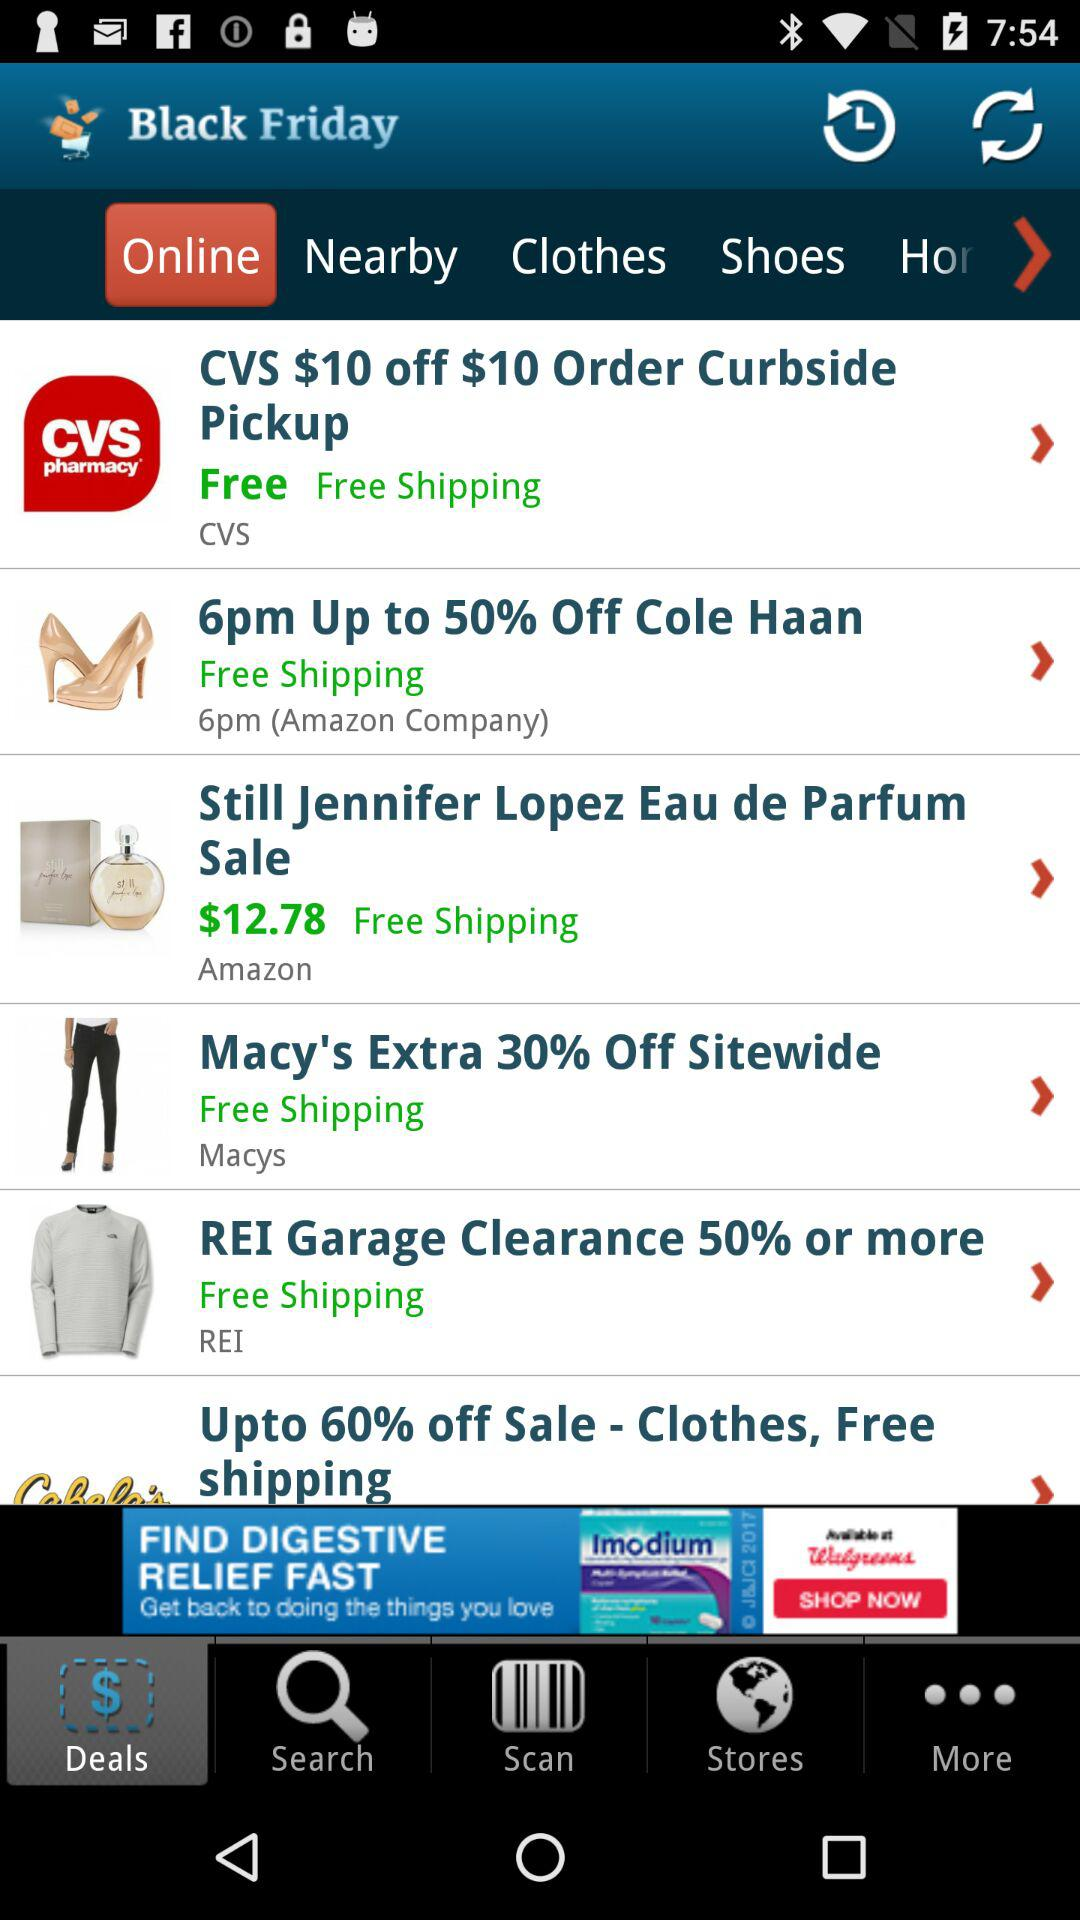How much of the percentage is off on clothes? On clothes, up to 60% is off. 